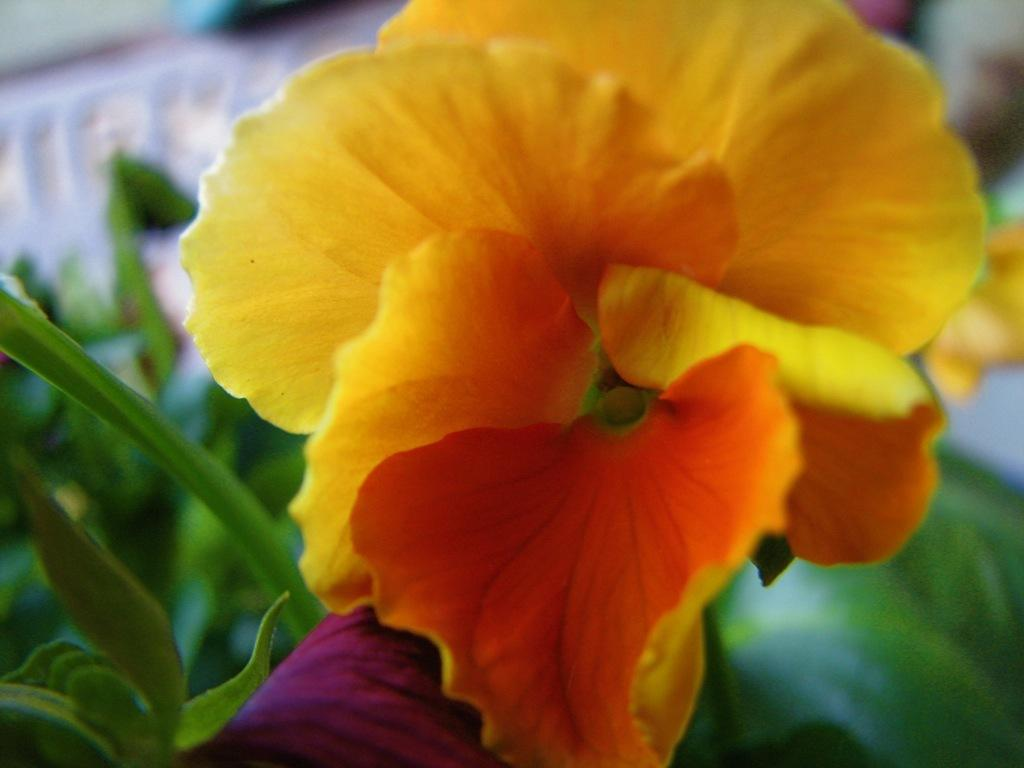What color is the flower in the image? The flower in the image is yellow. What other plant elements can be seen in the image besides the flower? There are green leaves in the image. What type of rice is being used to make a crown in the image? There is no rice or crown present in the image; it only features a yellow flower and green leaves. 